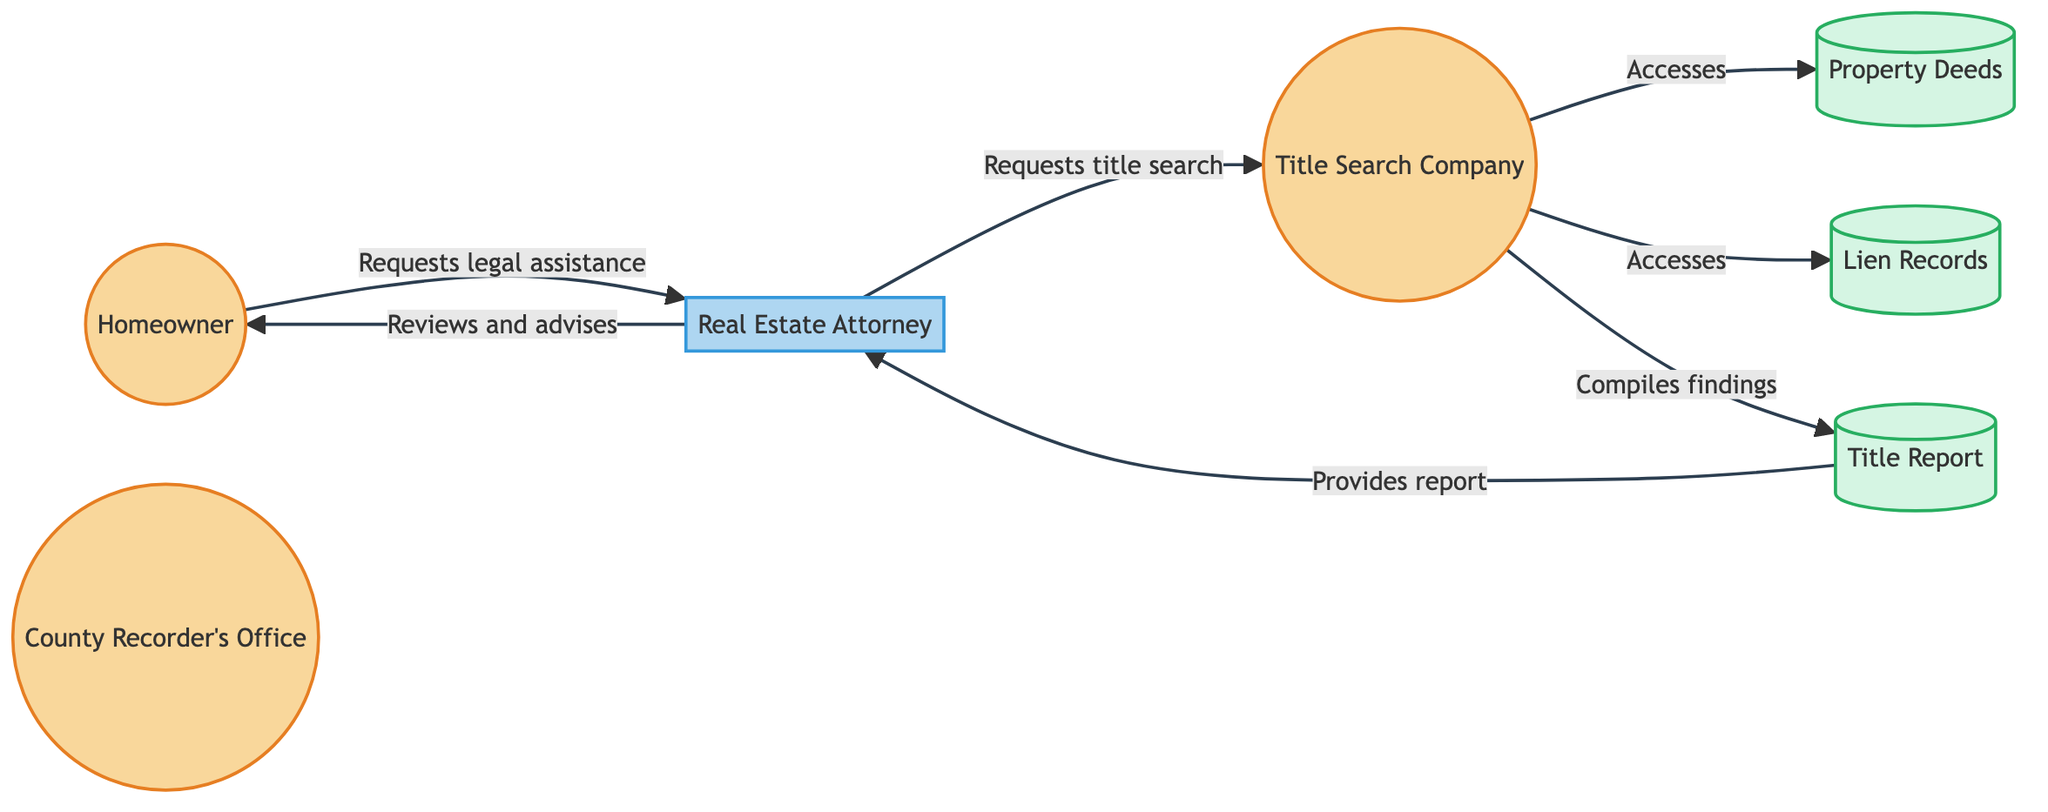What is the first entity that the Homeowner interacts with? The Homeowner interacts first with the Real Estate Attorney, as indicated by the arrow showing the request for legal assistance flowing from the Homeowner to the Attorney.
Answer: Real Estate Attorney How many processes are present in the diagram? In the diagram, there is one process labeled as "Real Estate Attorney." This is determined by counting the unique labeled boxes representing processes.
Answer: 1 What document is created after the Title Search Company completes its work? The Title Report is created once the Title Search Company compiles its findings, which is shown by the arrow directing from the Title Company to the Title Report.
Answer: Title Report What type of entity is the Title Search Company? The Title Search Company is classified as an External Entity, as indicated by the diagram's color coding and labeling.
Answer: External Entity Who provides the completed title report to the Real Estate Attorney? The Title Search Company is responsible for providing the completed title report to the Real Estate Attorney, which is shown by the directional flow from Title Report to Attorney.
Answer: Title Search Company Which external entity holds the Property Deeds? The County Recorder's Office holds the Property Deeds, as indicated in the description of this external entity in the diagram.
Answer: County Recorder's Office What relationship exists between the Real Estate Attorney and Homeowner after the title report is received? After the title report is received, the Real Estate Attorney reviews its content and advises the Homeowner on the findings and next steps, as reflected by the directional flow and description in the diagram.
Answer: Reviews and advises What type of records does the Title Search Company access to check for liens? The Title Search Company accesses Lien Records to check for any liens against the property, as indicated by the arrow from the Title Company to the Lien Records in the diagram.
Answer: Lien Records What is the role of the County Recorder's Office in the title search process? The County Recorder's Office maintains public records that the Title Search Company uses to access Property Deeds and Lien Records during the title search process.
Answer: Maintains public records 